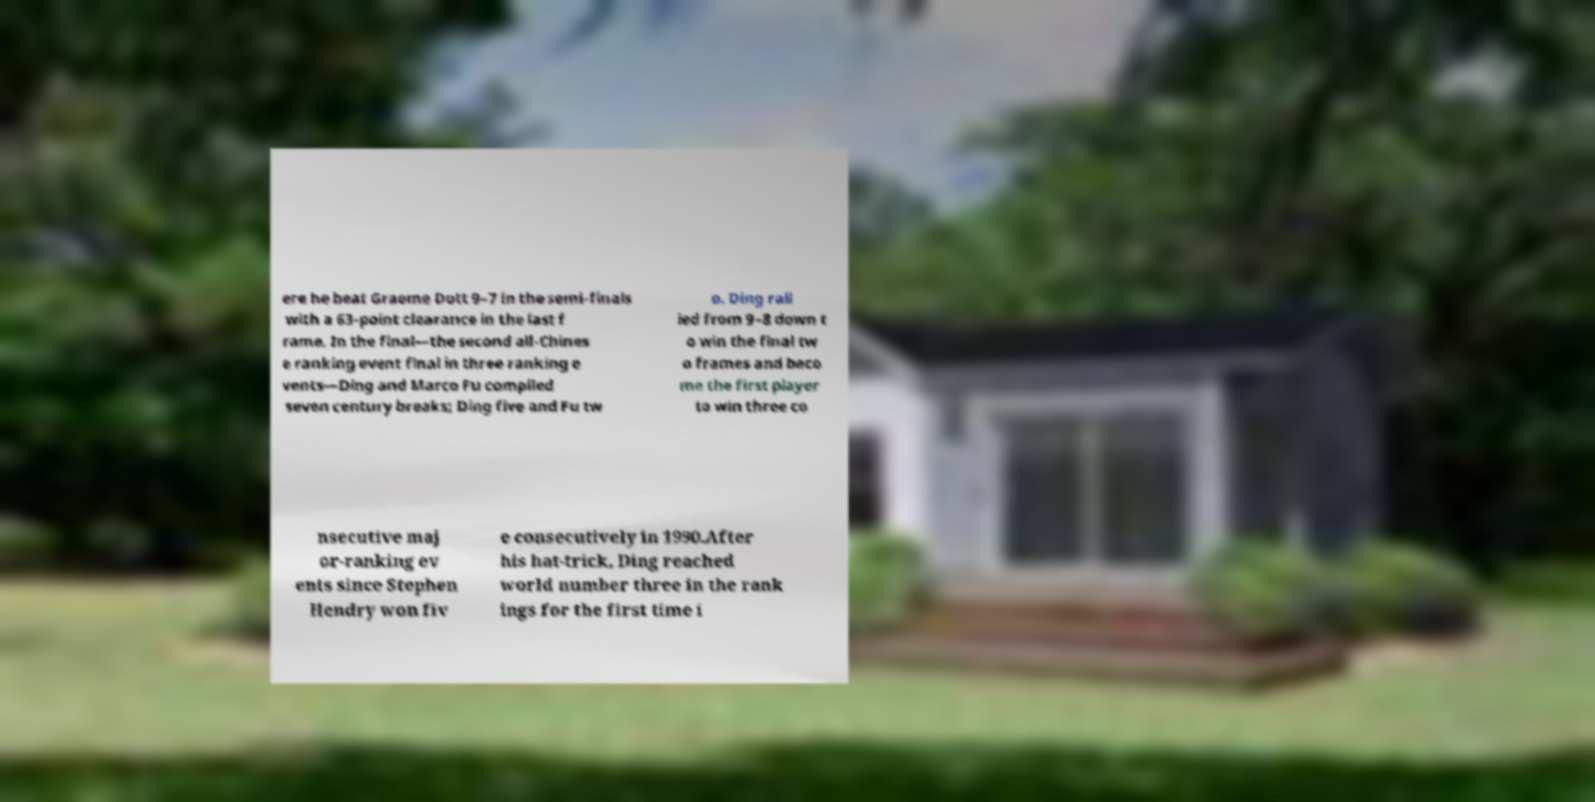Could you assist in decoding the text presented in this image and type it out clearly? ere he beat Graeme Dott 9–7 in the semi-finals with a 63-point clearance in the last f rame. In the final—the second all-Chines e ranking event final in three ranking e vents—Ding and Marco Fu compiled seven century breaks; Ding five and Fu tw o. Ding rall ied from 9–8 down t o win the final tw o frames and beco me the first player to win three co nsecutive maj or-ranking ev ents since Stephen Hendry won fiv e consecutively in 1990.After his hat-trick, Ding reached world number three in the rank ings for the first time i 